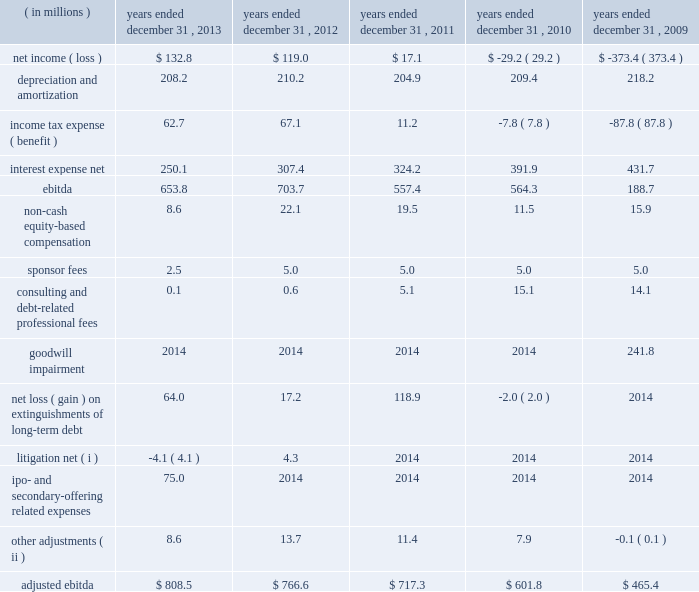( 2 ) for purposes of calculating the ratio of earnings to fixed charges , earnings consist of earnings before income taxes minus income from equity investees plus fixed charges .
Fixed charges consist of interest expense and the portion of rental expense we believe is representative of the interest component of rental expense .
( a ) for the years ended december 31 , 2010 and 2009 , earnings available for fixed charges were inadequate to cover fixed charges by $ 37.0 million and $ 461.2 million , respectively .
( 3 ) ebitda is defined as consolidated net income ( loss ) before interest expense , income tax expense ( benefit ) , depreciation , and amortization .
Adjusted ebitda , which is a measure defined in our credit agreements , is calculated by adjusting ebitda for certain items of income and expense including ( but not limited to ) the following : ( a ) non-cash equity-based compensation ; ( b ) goodwill impairment charges ; ( c ) sponsor fees ; ( d ) certain consulting fees ; ( e ) debt-related legal and accounting costs ; ( f ) equity investment income and losses ; ( g ) certain severance and retention costs ; ( h ) gains and losses from the early extinguishment of debt ; ( i ) gains and losses from asset dispositions outside the ordinary course of business ; and ( j ) non-recurring , extraordinary or unusual gains or losses or expenses .
We have included a reconciliation of ebitda and adjusted ebitda in the table below .
Both ebitda and adjusted ebitda are considered non-gaap financial measures .
Generally , a non-gaap financial measure is a numerical measure of a company 2019s performance , financial position or cash flows that either excludes or includes amounts that are not normally included or excluded in the most directly comparable measure calculated and presented in accordance with gaap .
Non-gaap measures used by the company may differ from similar measures used by other companies , even when similar terms are used to identify such measures .
We believe that ebitda and adjusted ebitda provide helpful information with respect to our operating performance and cash flows including our ability to meet our future debt service , capital expenditures and working capital requirements .
Adjusted ebitda also provides helpful information as it is the primary measure used in certain financial covenants contained in our credit agreements .
The following unaudited table sets forth reconciliations of net income ( loss ) to ebitda and ebitda to adjusted ebitda for the periods presented: .
( i ) relates to unusual , non-recurring litigation matters .
( ii ) includes certain retention costs and equity investment income , certain severance costs in 2009 and a gain related to the sale of the informacast software and equipment in 2009. .
3 net income ( loss ) $ 132.8 \\n5 income tax expense ( benefit ) 62.7? 
Rationale: taxes divided by pretax income
Computations: (62.7 / (62.7 + 132.8))
Answer: 0.32072. 